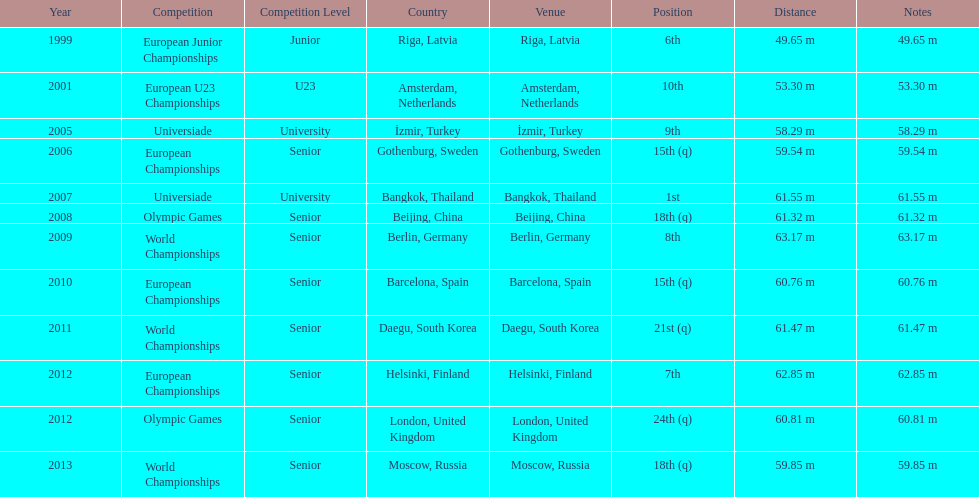How many global championships has he participated in? 3. 